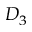Convert formula to latex. <formula><loc_0><loc_0><loc_500><loc_500>D _ { 3 }</formula> 